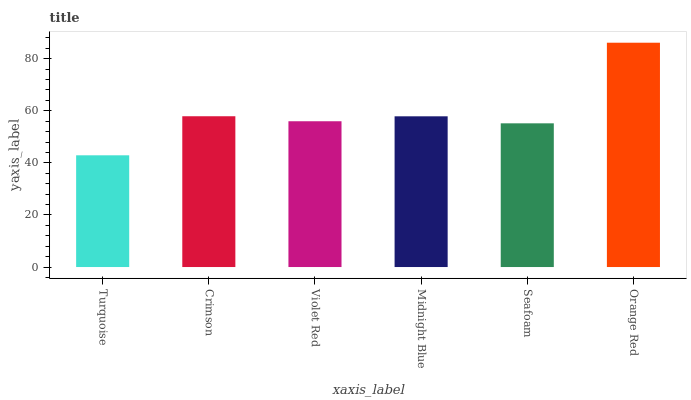Is Turquoise the minimum?
Answer yes or no. Yes. Is Orange Red the maximum?
Answer yes or no. Yes. Is Crimson the minimum?
Answer yes or no. No. Is Crimson the maximum?
Answer yes or no. No. Is Crimson greater than Turquoise?
Answer yes or no. Yes. Is Turquoise less than Crimson?
Answer yes or no. Yes. Is Turquoise greater than Crimson?
Answer yes or no. No. Is Crimson less than Turquoise?
Answer yes or no. No. Is Midnight Blue the high median?
Answer yes or no. Yes. Is Violet Red the low median?
Answer yes or no. Yes. Is Seafoam the high median?
Answer yes or no. No. Is Seafoam the low median?
Answer yes or no. No. 